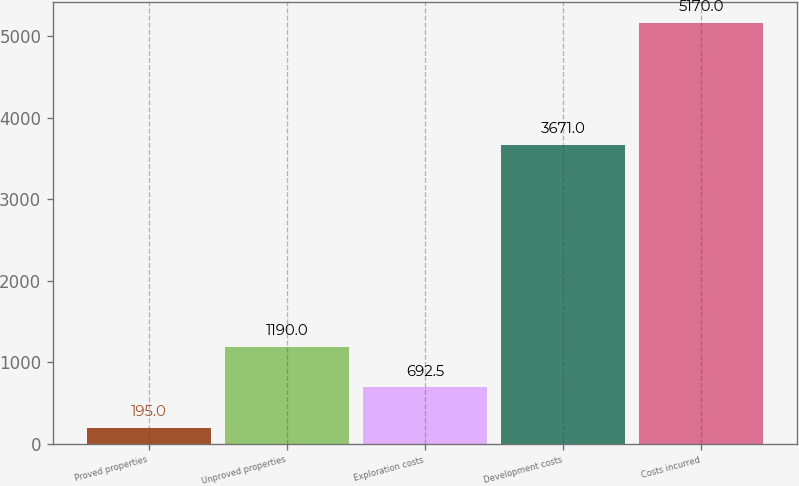Convert chart to OTSL. <chart><loc_0><loc_0><loc_500><loc_500><bar_chart><fcel>Proved properties<fcel>Unproved properties<fcel>Exploration costs<fcel>Development costs<fcel>Costs incurred<nl><fcel>195<fcel>1190<fcel>692.5<fcel>3671<fcel>5170<nl></chart> 